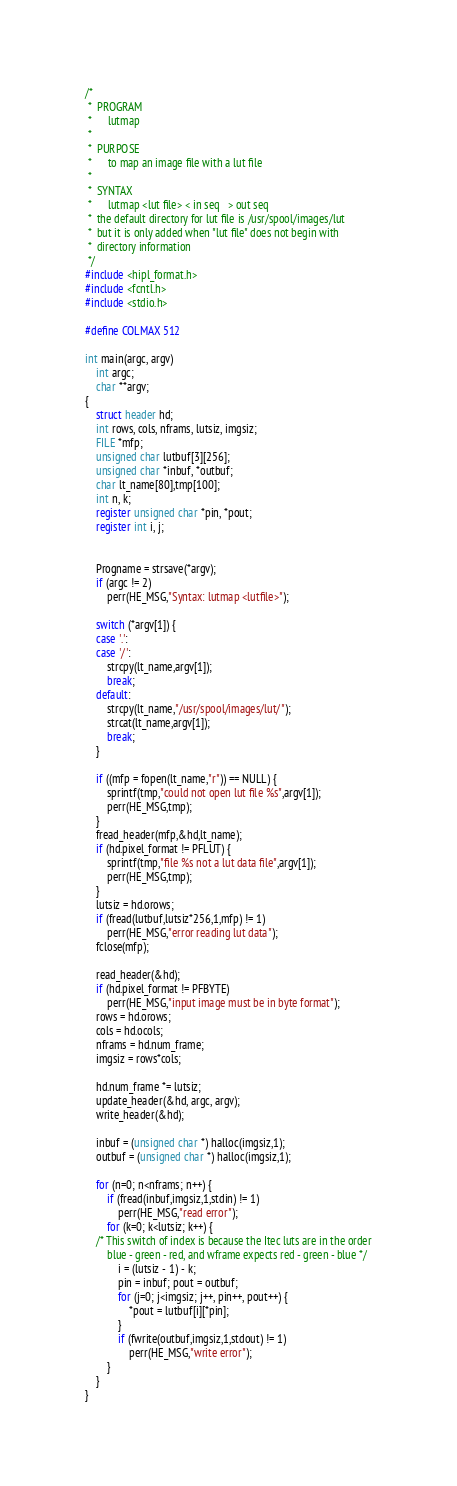Convert code to text. <code><loc_0><loc_0><loc_500><loc_500><_C_>/*
 *	PROGRAM
 *		lutmap
 *
 *	PURPOSE
 *		to map an image file with a lut file
 *
 *	SYNTAX
 *		lutmap <lut file> < in seq   > out seq
 *	the default directory for lut file is /usr/spool/images/lut
 *	but it is only added when "lut file" does not begin with
 *	directory information
 */
#include <hipl_format.h>
#include <fcntl.h>
#include <stdio.h>

#define COLMAX 512

int main(argc, argv)
	int argc;
	char **argv;
{
	struct header hd;
	int rows, cols, nframs, lutsiz, imgsiz;
	FILE *mfp;
	unsigned char lutbuf[3][256];
	unsigned char *inbuf, *outbuf;
	char lt_name[80],tmp[100];
	int n, k;
	register unsigned char *pin, *pout;
	register int i, j;


	Progname = strsave(*argv);
	if (argc != 2)
		perr(HE_MSG,"Syntax: lutmap <lutfile>");

	switch (*argv[1]) {
	case '.':
	case '/':
		strcpy(lt_name,argv[1]);
		break;
	default:
		strcpy(lt_name,"/usr/spool/images/lut/");
		strcat(lt_name,argv[1]);
		break;
	}

	if ((mfp = fopen(lt_name,"r")) == NULL) {
		sprintf(tmp,"could not open lut file %s",argv[1]);
		perr(HE_MSG,tmp);
	}
	fread_header(mfp,&hd,lt_name);
	if (hd.pixel_format != PFLUT) {
		sprintf(tmp,"file %s not a lut data file",argv[1]);
		perr(HE_MSG,tmp);
	}
	lutsiz = hd.orows;
	if (fread(lutbuf,lutsiz*256,1,mfp) != 1)
		perr(HE_MSG,"error reading lut data");
	fclose(mfp);

	read_header(&hd);
	if (hd.pixel_format != PFBYTE)
		perr(HE_MSG,"input image must be in byte format");
	rows = hd.orows;
	cols = hd.ocols;
	nframs = hd.num_frame;
	imgsiz = rows*cols;

	hd.num_frame *= lutsiz;
	update_header(&hd, argc, argv);
	write_header(&hd);

	inbuf = (unsigned char *) halloc(imgsiz,1);
	outbuf = (unsigned char *) halloc(imgsiz,1);

	for (n=0; n<nframs; n++) {
		if (fread(inbuf,imgsiz,1,stdin) != 1)
			perr(HE_MSG,"read error");
		for (k=0; k<lutsiz; k++) {
	/* This switch of index is because the Itec luts are in the order
		blue - green - red, and wframe expects red - green - blue */
			i = (lutsiz - 1) - k;
			pin = inbuf; pout = outbuf;
			for (j=0; j<imgsiz; j++, pin++, pout++) {
				*pout = lutbuf[i][*pin];
			}
			if (fwrite(outbuf,imgsiz,1,stdout) != 1)
				perr(HE_MSG,"write error");
		}
	}
}
</code> 